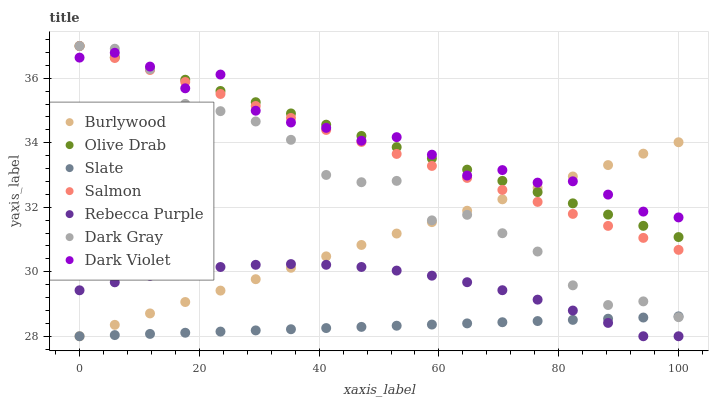Does Slate have the minimum area under the curve?
Answer yes or no. Yes. Does Dark Violet have the maximum area under the curve?
Answer yes or no. Yes. Does Salmon have the minimum area under the curve?
Answer yes or no. No. Does Salmon have the maximum area under the curve?
Answer yes or no. No. Is Slate the smoothest?
Answer yes or no. Yes. Is Dark Gray the roughest?
Answer yes or no. Yes. Is Salmon the smoothest?
Answer yes or no. No. Is Salmon the roughest?
Answer yes or no. No. Does Burlywood have the lowest value?
Answer yes or no. Yes. Does Salmon have the lowest value?
Answer yes or no. No. Does Olive Drab have the highest value?
Answer yes or no. Yes. Does Slate have the highest value?
Answer yes or no. No. Is Rebecca Purple less than Dark Gray?
Answer yes or no. Yes. Is Dark Violet greater than Slate?
Answer yes or no. Yes. Does Olive Drab intersect Dark Violet?
Answer yes or no. Yes. Is Olive Drab less than Dark Violet?
Answer yes or no. No. Is Olive Drab greater than Dark Violet?
Answer yes or no. No. Does Rebecca Purple intersect Dark Gray?
Answer yes or no. No. 